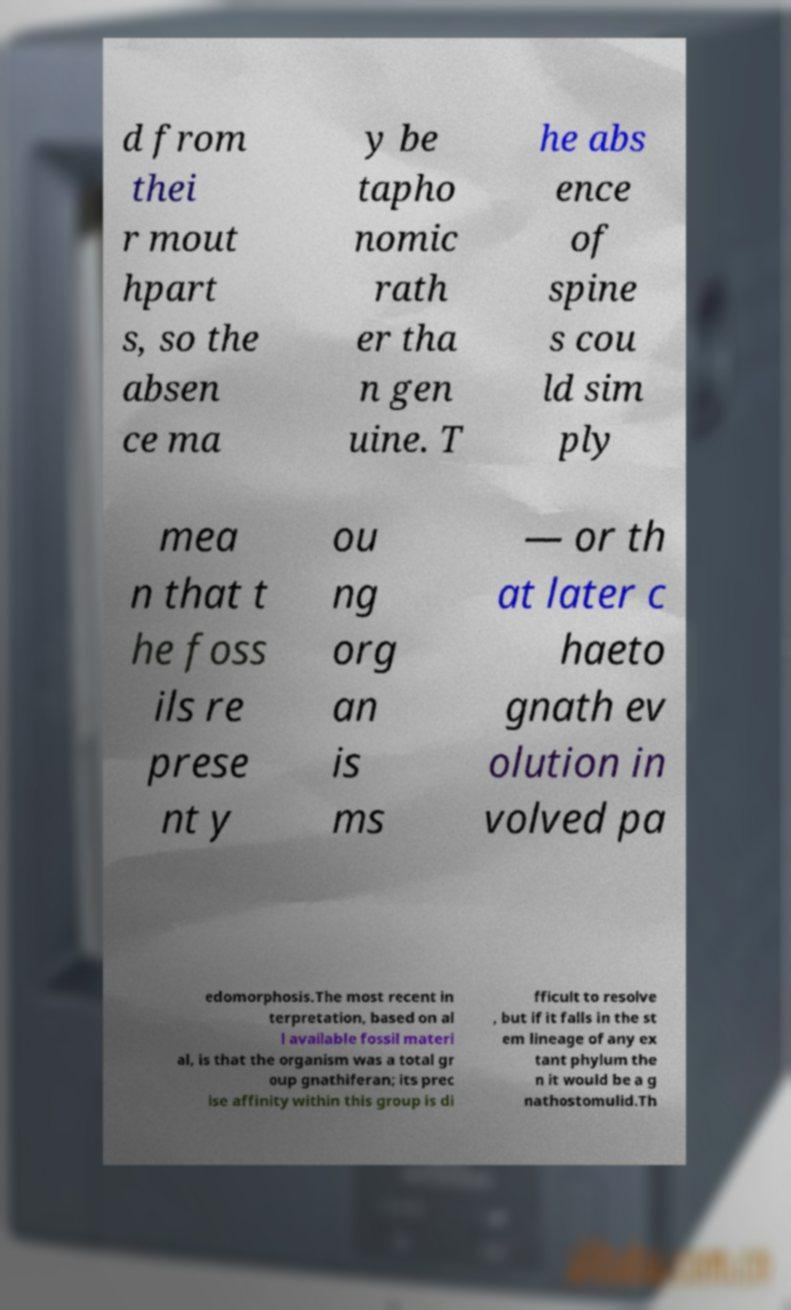Can you read and provide the text displayed in the image?This photo seems to have some interesting text. Can you extract and type it out for me? d from thei r mout hpart s, so the absen ce ma y be tapho nomic rath er tha n gen uine. T he abs ence of spine s cou ld sim ply mea n that t he foss ils re prese nt y ou ng org an is ms — or th at later c haeto gnath ev olution in volved pa edomorphosis.The most recent in terpretation, based on al l available fossil materi al, is that the organism was a total gr oup gnathiferan; its prec ise affinity within this group is di fficult to resolve , but if it falls in the st em lineage of any ex tant phylum the n it would be a g nathostomulid.Th 